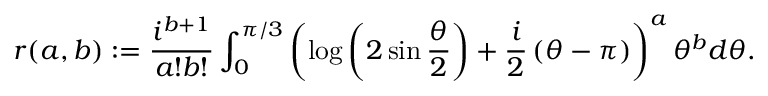Convert formula to latex. <formula><loc_0><loc_0><loc_500><loc_500>r ( a , b ) \colon = \frac { i ^ { b + 1 } } { a ! b ! } \int _ { 0 } ^ { \pi / 3 } \left ( \log \left ( 2 \sin \frac { \theta } { 2 } \right ) + \frac { i } { 2 } \left ( \theta - \pi \right ) \right ) ^ { a } \theta ^ { b } d \theta .</formula> 